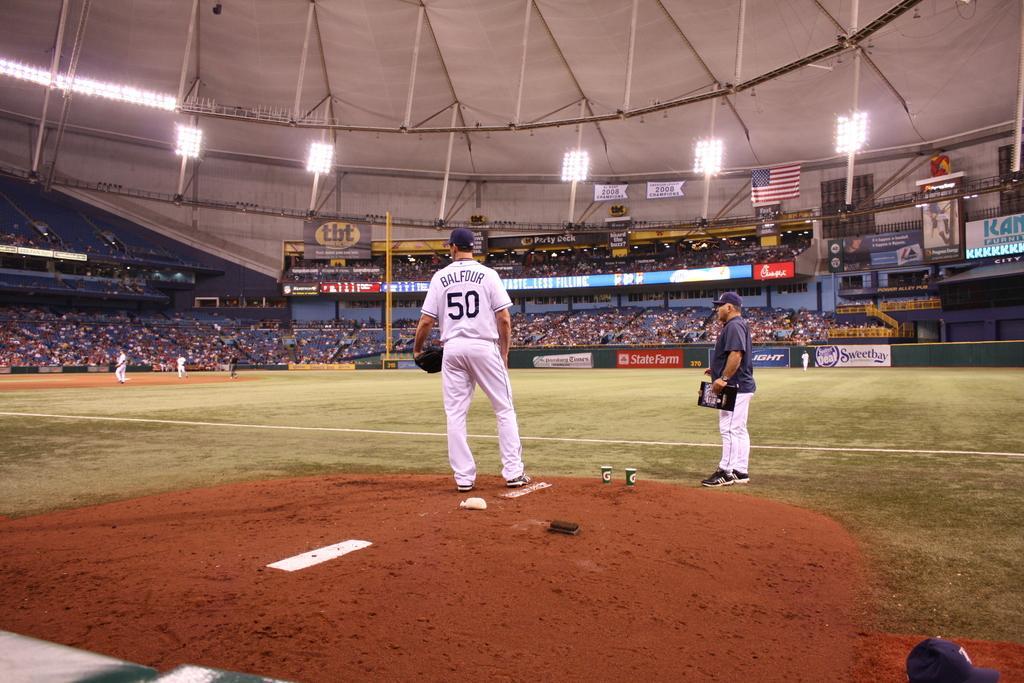Please provide a concise description of this image. This is an inside view of a stadium. In the middle of the image there are two men standing and looking at the left side. On the left side there are few persons running on the ground. In the background, I can see a crowd of people in the stadium. On the right side there are few boards on which, I can see the text. At the top there are few lights attached to the metal rods. 